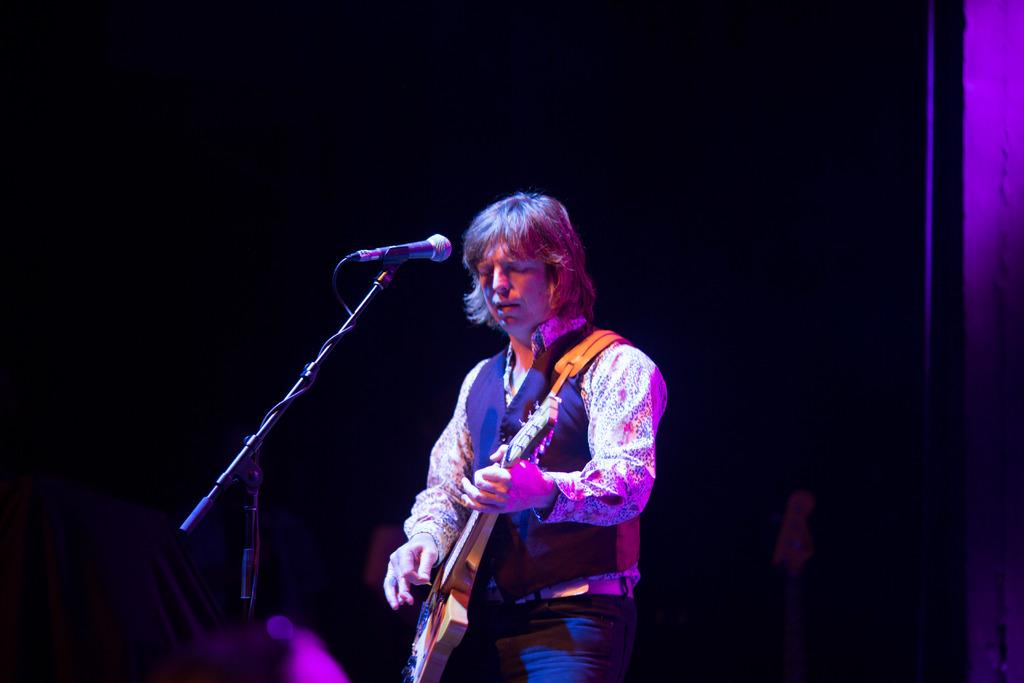What is the main subject of the image? There is a person standing in the middle of the image. What is the person holding in the image? The person is holding a guitar. Can you identify any other objects in the image? Yes, there is a microphone in the image. What type of cream can be seen being applied to the person's face in the image? There is no cream being applied to the person's face in the image. What kind of spark can be seen coming from the guitar in the image? There is no spark coming from the guitar in the image. 